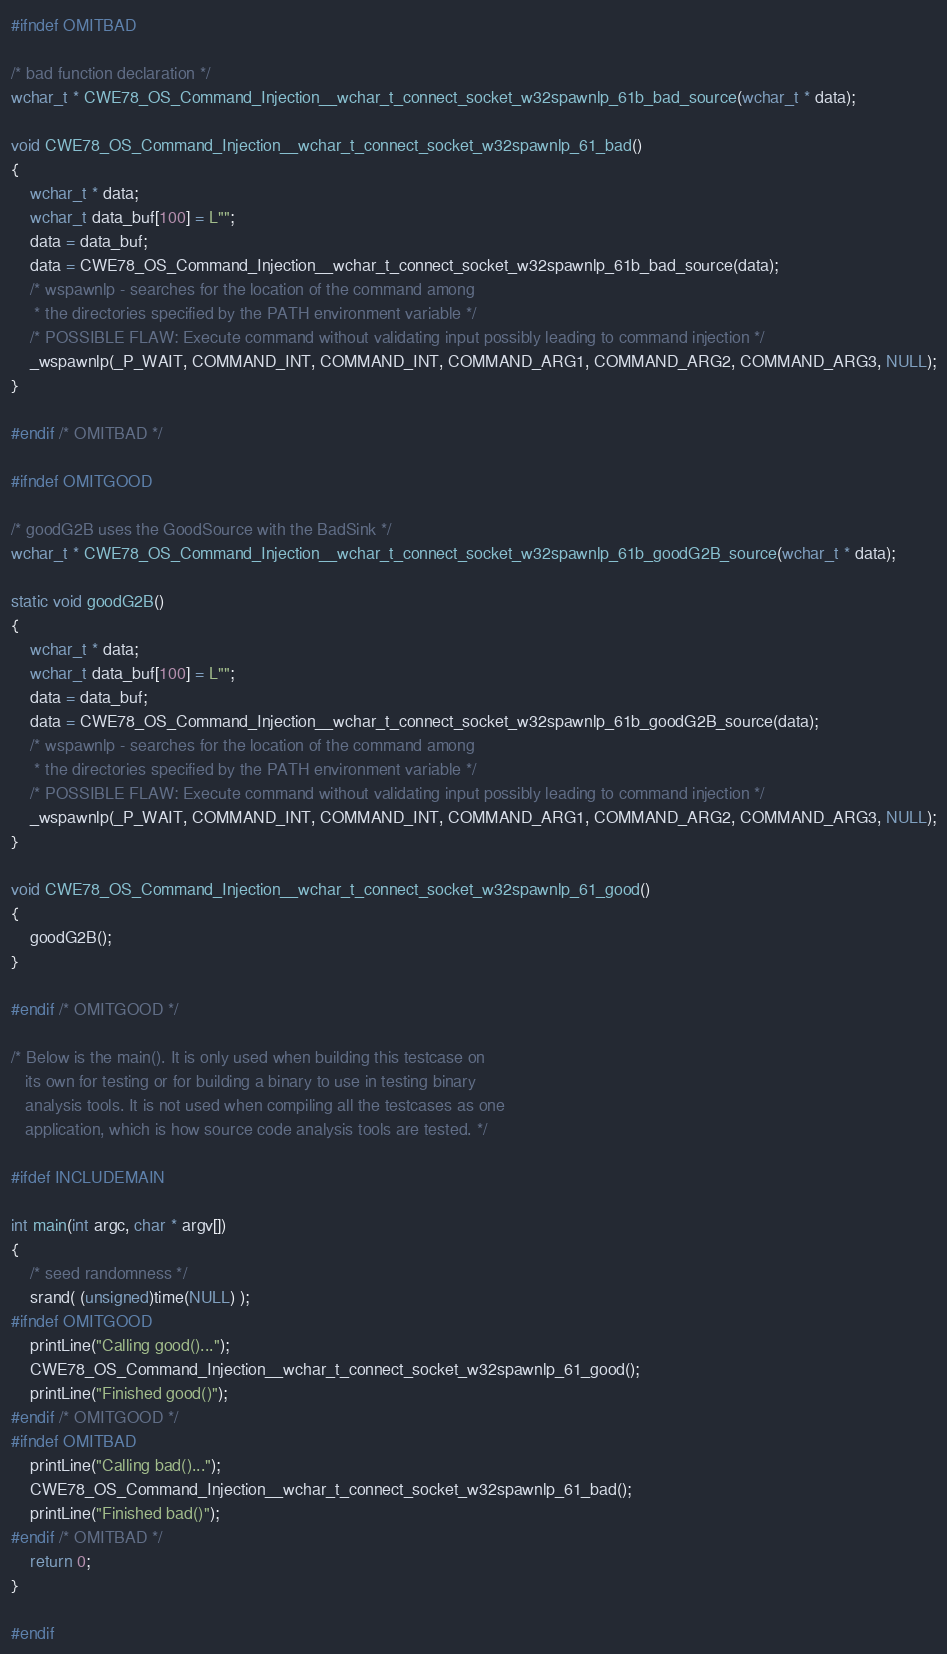<code> <loc_0><loc_0><loc_500><loc_500><_C_>
#ifndef OMITBAD

/* bad function declaration */
wchar_t * CWE78_OS_Command_Injection__wchar_t_connect_socket_w32spawnlp_61b_bad_source(wchar_t * data);

void CWE78_OS_Command_Injection__wchar_t_connect_socket_w32spawnlp_61_bad()
{
    wchar_t * data;
    wchar_t data_buf[100] = L"";
    data = data_buf;
    data = CWE78_OS_Command_Injection__wchar_t_connect_socket_w32spawnlp_61b_bad_source(data);
    /* wspawnlp - searches for the location of the command among
     * the directories specified by the PATH environment variable */
    /* POSSIBLE FLAW: Execute command without validating input possibly leading to command injection */
    _wspawnlp(_P_WAIT, COMMAND_INT, COMMAND_INT, COMMAND_ARG1, COMMAND_ARG2, COMMAND_ARG3, NULL);
}

#endif /* OMITBAD */

#ifndef OMITGOOD

/* goodG2B uses the GoodSource with the BadSink */
wchar_t * CWE78_OS_Command_Injection__wchar_t_connect_socket_w32spawnlp_61b_goodG2B_source(wchar_t * data);

static void goodG2B()
{
    wchar_t * data;
    wchar_t data_buf[100] = L"";
    data = data_buf;
    data = CWE78_OS_Command_Injection__wchar_t_connect_socket_w32spawnlp_61b_goodG2B_source(data);
    /* wspawnlp - searches for the location of the command among
     * the directories specified by the PATH environment variable */
    /* POSSIBLE FLAW: Execute command without validating input possibly leading to command injection */
    _wspawnlp(_P_WAIT, COMMAND_INT, COMMAND_INT, COMMAND_ARG1, COMMAND_ARG2, COMMAND_ARG3, NULL);
}

void CWE78_OS_Command_Injection__wchar_t_connect_socket_w32spawnlp_61_good()
{
    goodG2B();
}

#endif /* OMITGOOD */

/* Below is the main(). It is only used when building this testcase on
   its own for testing or for building a binary to use in testing binary
   analysis tools. It is not used when compiling all the testcases as one
   application, which is how source code analysis tools are tested. */

#ifdef INCLUDEMAIN

int main(int argc, char * argv[])
{
    /* seed randomness */
    srand( (unsigned)time(NULL) );
#ifndef OMITGOOD
    printLine("Calling good()...");
    CWE78_OS_Command_Injection__wchar_t_connect_socket_w32spawnlp_61_good();
    printLine("Finished good()");
#endif /* OMITGOOD */
#ifndef OMITBAD
    printLine("Calling bad()...");
    CWE78_OS_Command_Injection__wchar_t_connect_socket_w32spawnlp_61_bad();
    printLine("Finished bad()");
#endif /* OMITBAD */
    return 0;
}

#endif
</code> 